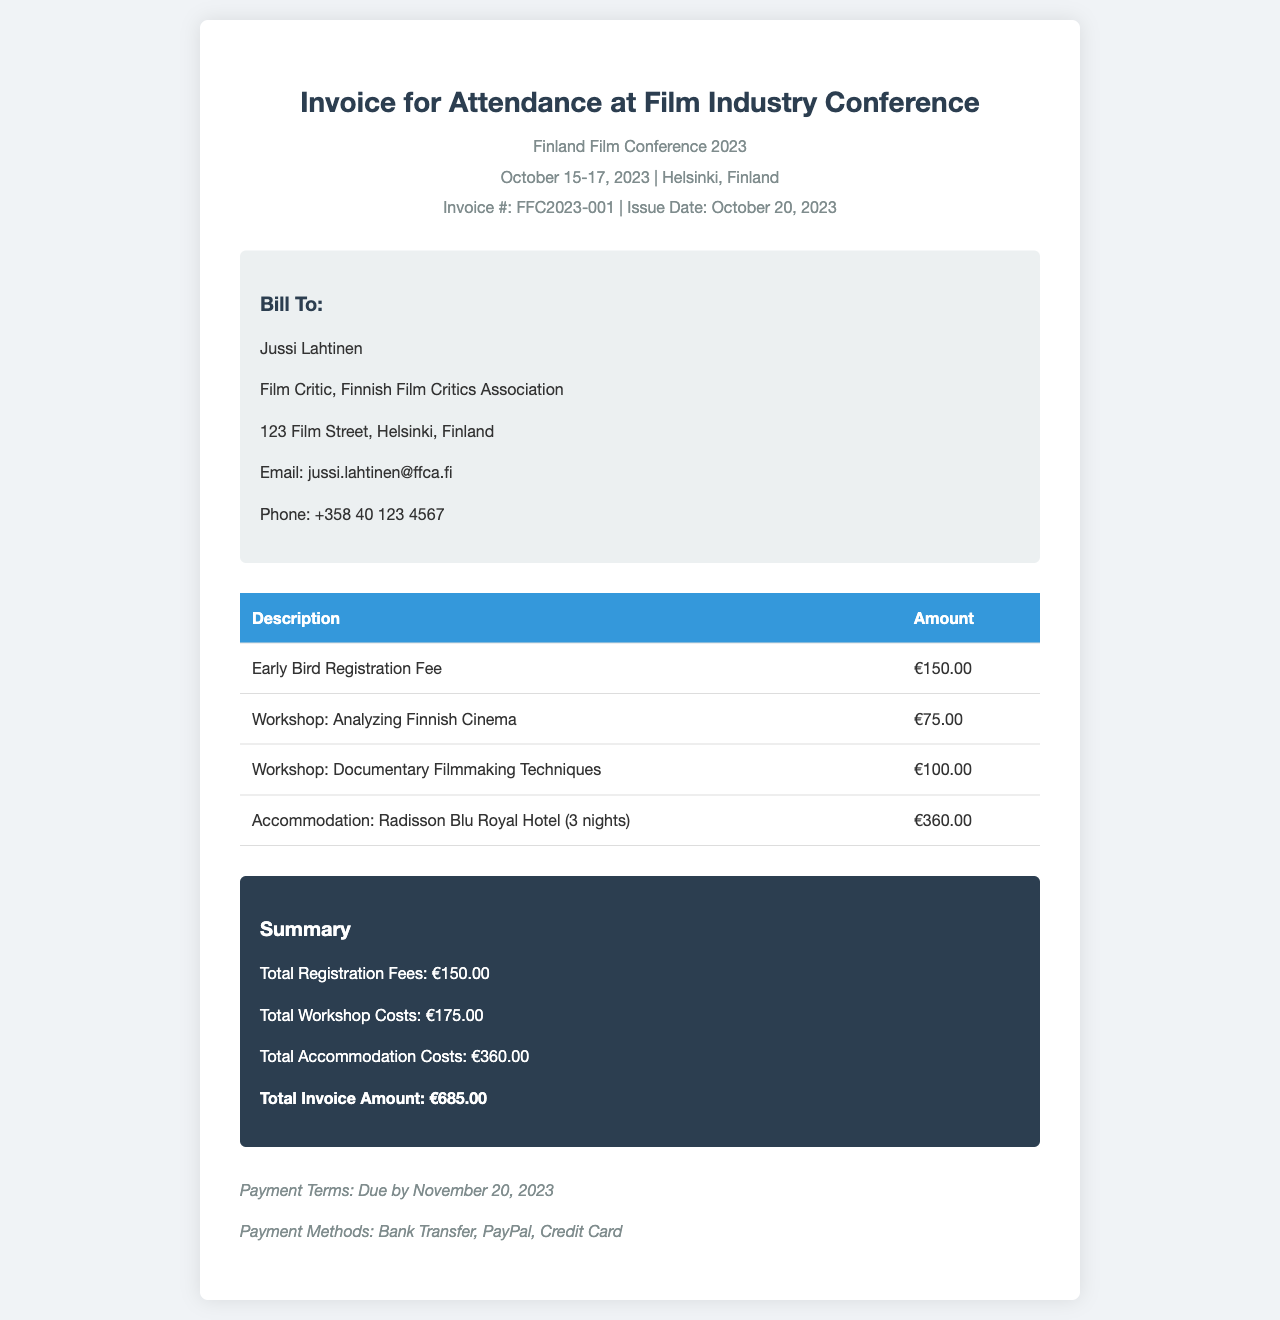What is the invoice number? The invoice number is listed at the top of the document.
Answer: FFC2023-001 Who is the bill to? The name of the person being billed is provided in the "Bill To" section.
Answer: Jussi Lahtinen What is the total accommodation cost? The total accommodation cost is calculated based on the detailed breakdown in the invoice.
Answer: €360.00 What are the payment terms? The payment terms indicate when the payment is due and are found at the end of the document.
Answer: Due by November 20, 2023 How many workshops were attended? The number of workshops can be counted from the details provided in the table.
Answer: 2 What is the total invoice amount? The total invoice amount is summarized at the bottom of the invoice.
Answer: €685.00 What is the date of the conference? The conference dates are included in the header section.
Answer: October 15-17, 2023 What are the available payment methods? The payment methods are listed in the payment terms section of the invoice.
Answer: Bank Transfer, PayPal, Credit Card What is the issue date of the invoice? The issue date is specified under the invoice number near the top of the document.
Answer: October 20, 2023 